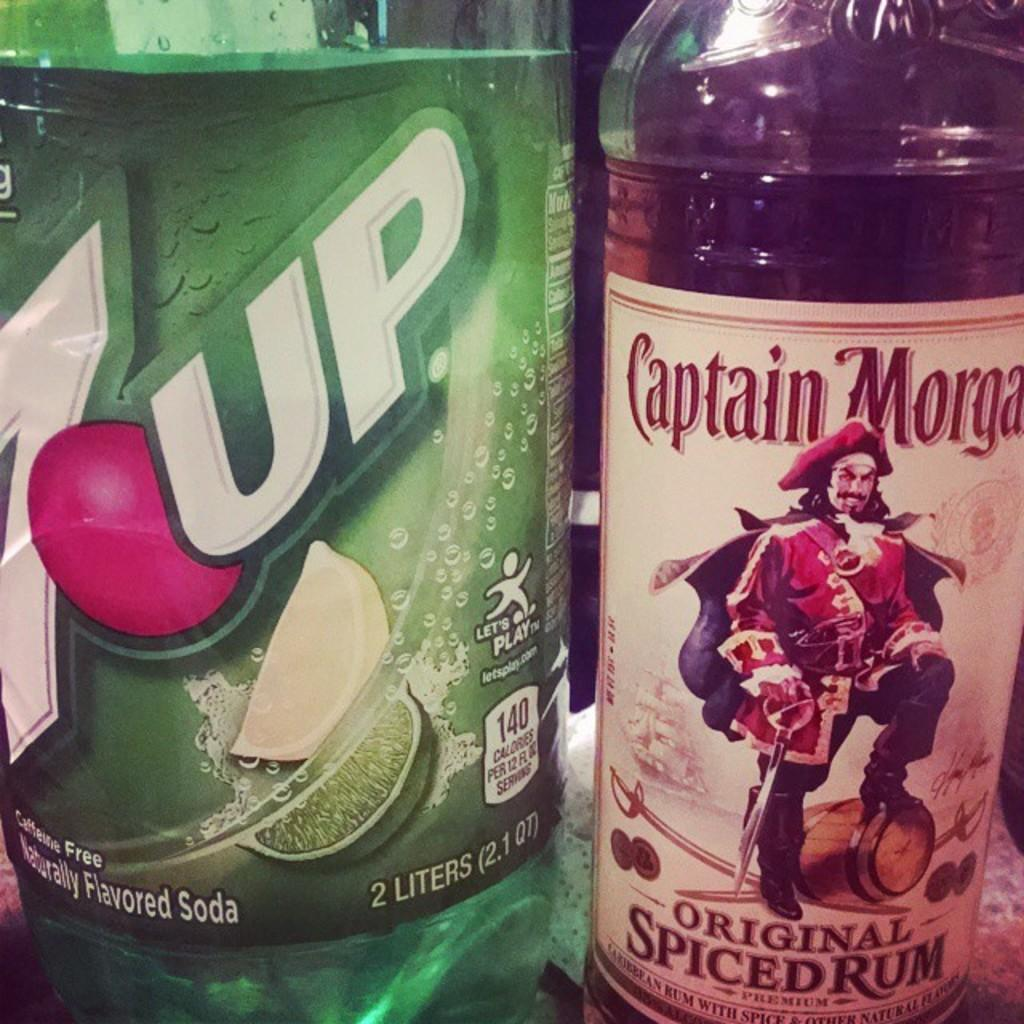<image>
Give a short and clear explanation of the subsequent image. A bottle of 7up is sitting next to a bottle of Captain Morgans. 